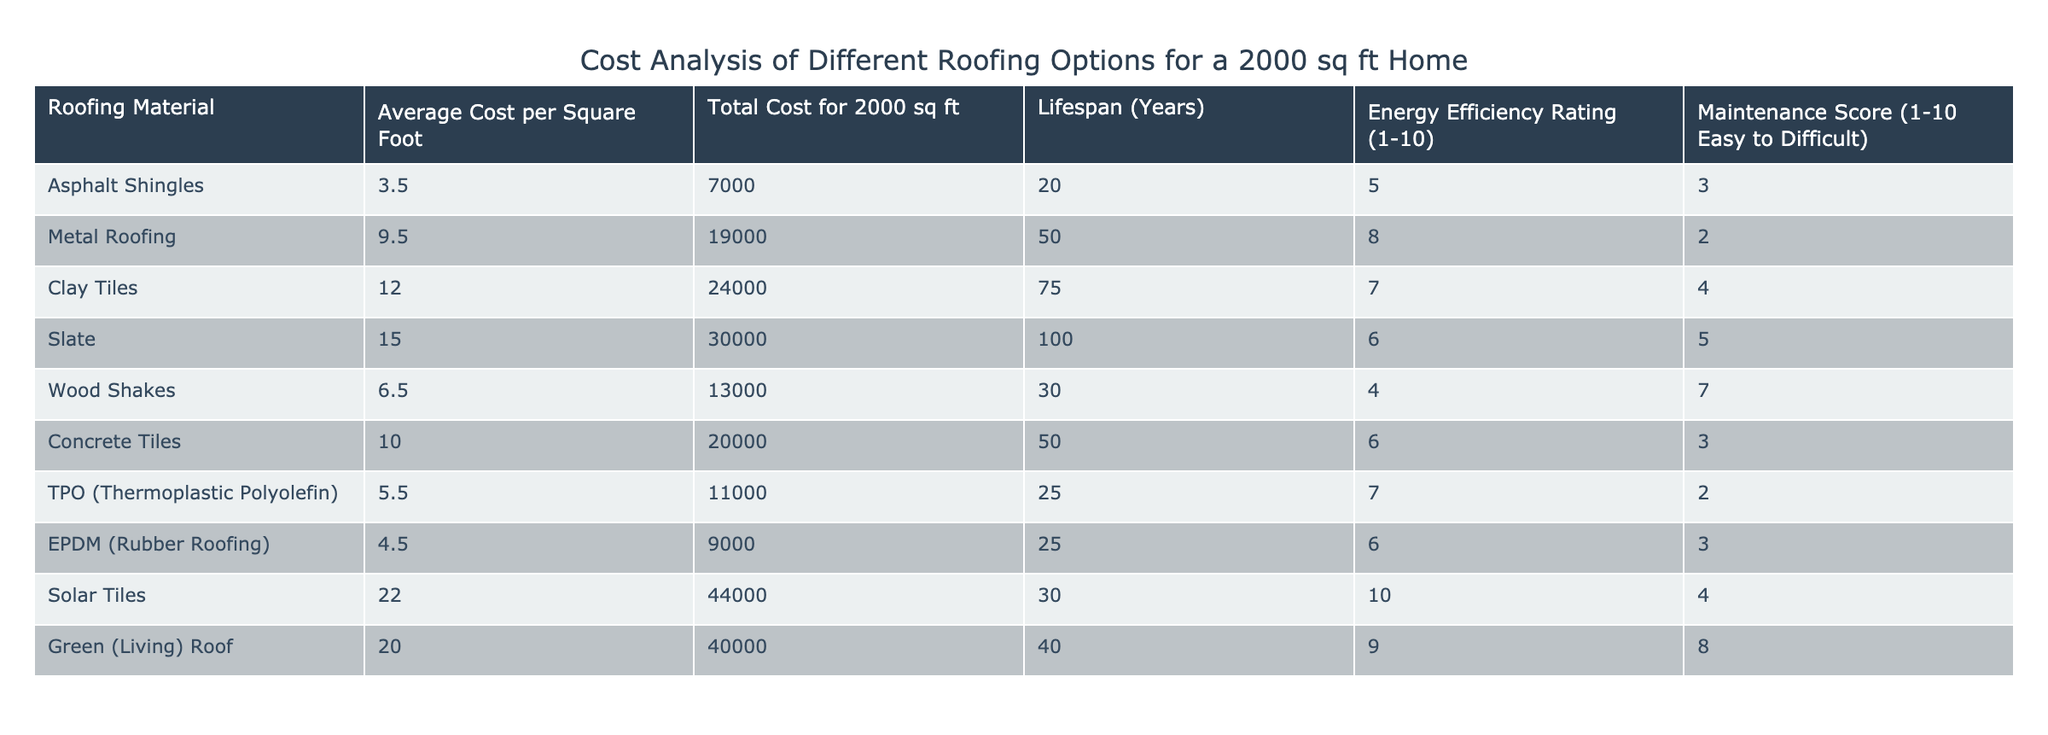What is the total cost of asphalt shingles for a 2000 sq ft home? According to the table, the total cost for asphalt shingles is directly listed as 7000.
Answer: 7000 How long does metal roofing typically last? The table indicates that metal roofing has a lifespan of 50 years.
Answer: 50 years Which roofing material has the highest energy efficiency rating? By examining the energy efficiency ratings in the table, solar tiles have the highest score of 10.
Answer: 10 What is the average cost per square foot of wood shakes and concrete tiles? The cost per square foot for wood shakes is 6.50 and for concrete tiles is 10.00. The average cost is calculated as (6.50 + 10.00) / 2 = 8.25.
Answer: 8.25 Is the maintenance score of clay tiles higher than that of metal roofing? The table shows that clay tiles have a maintenance score of 4 while metal roofing has a score of 2. Since 4 is higher than 2, the answer is yes.
Answer: Yes What is the total cost difference between solar tiles and green roofs? The total cost for solar tiles is 44000 and for green roofs is 40000. The difference is calculated as 44000 - 40000 = 4000.
Answer: 4000 How many roofing materials have a lifespan greater than 50 years? By checking the lifespan column, clay tiles (75 years) and slate (100 years) are the materials that last longer than 50 years. There are 2 such materials.
Answer: 2 Is it true that TPO roofing has a lower energy efficiency rating than wood shakes? TPO has an energy efficiency rating of 7, while wood shakes have a rating of 4. Since 7 is higher than 4, this statement is false.
Answer: No Which roofing material has the highest total cost, and what is that cost? The table lists solar tiles with the highest total cost of 44000.
Answer: 44000 